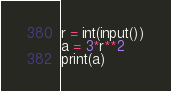<code> <loc_0><loc_0><loc_500><loc_500><_Python_>r = int(input())
a = 3*r**2
print(a)</code> 